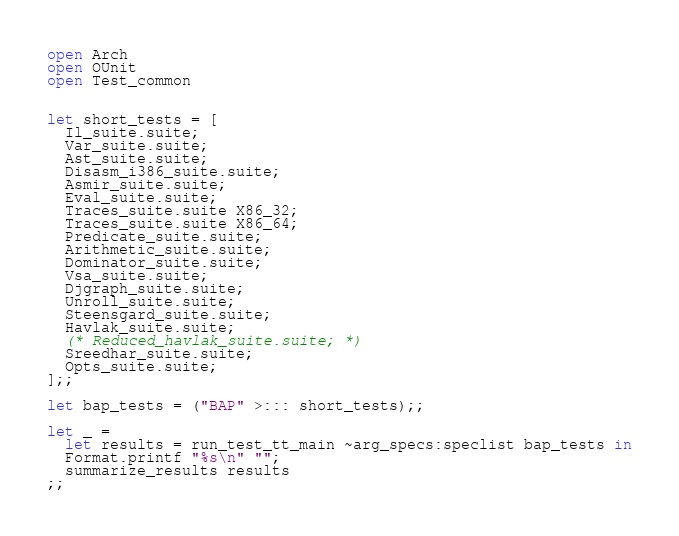Convert code to text. <code><loc_0><loc_0><loc_500><loc_500><_OCaml_>open Arch
open OUnit
open Test_common


let short_tests = [
  Il_suite.suite;
  Var_suite.suite;
  Ast_suite.suite;
  Disasm_i386_suite.suite;
  Asmir_suite.suite;
  Eval_suite.suite;
  Traces_suite.suite X86_32;
  Traces_suite.suite X86_64;
  Predicate_suite.suite;
  Arithmetic_suite.suite;
  Dominator_suite.suite;
  Vsa_suite.suite;
  Djgraph_suite.suite;
  Unroll_suite.suite;
  Steensgard_suite.suite;
  Havlak_suite.suite;
  (* Reduced_havlak_suite.suite; *)
  Sreedhar_suite.suite;
  Opts_suite.suite;
];;

let bap_tests = ("BAP" >::: short_tests);;

let _ =
  let results = run_test_tt_main ~arg_specs:speclist bap_tests in
  Format.printf "%s\n" "";
  summarize_results results
;;
</code> 